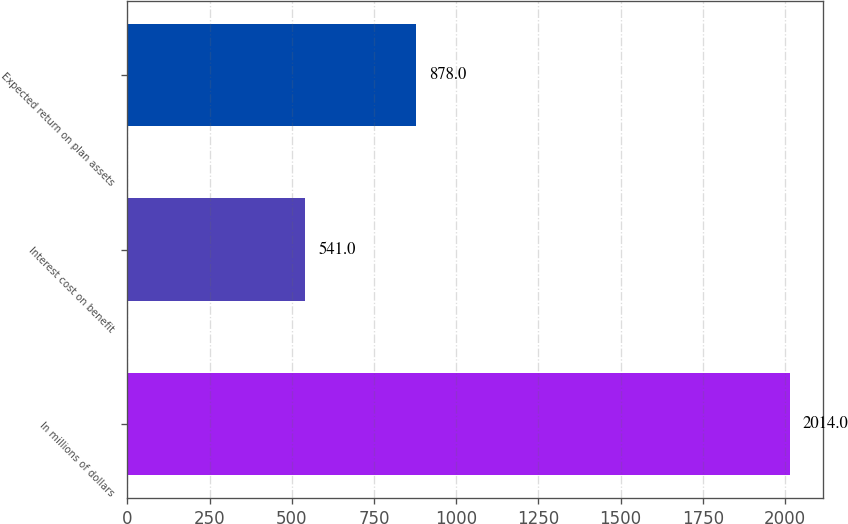<chart> <loc_0><loc_0><loc_500><loc_500><bar_chart><fcel>In millions of dollars<fcel>Interest cost on benefit<fcel>Expected return on plan assets<nl><fcel>2014<fcel>541<fcel>878<nl></chart> 